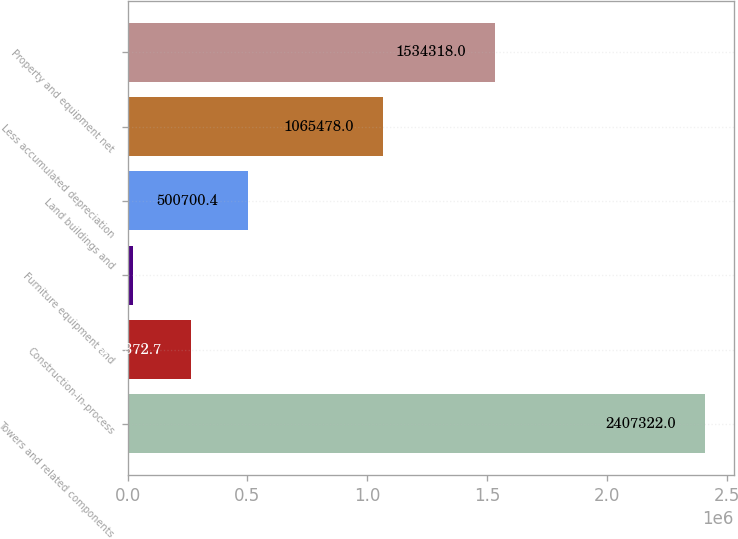Convert chart to OTSL. <chart><loc_0><loc_0><loc_500><loc_500><bar_chart><fcel>Towers and related components<fcel>Construction-in-process<fcel>Furniture equipment and<fcel>Land buildings and<fcel>Less accumulated depreciation<fcel>Property and equipment net<nl><fcel>2.40732e+06<fcel>262373<fcel>24045<fcel>500700<fcel>1.06548e+06<fcel>1.53432e+06<nl></chart> 